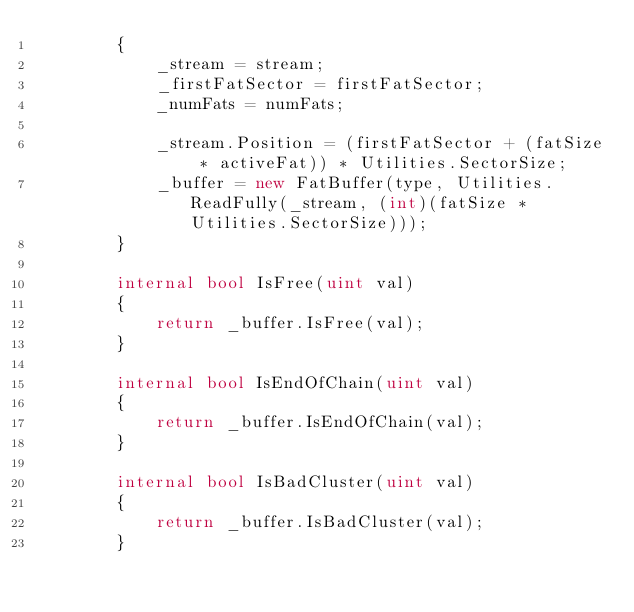Convert code to text. <code><loc_0><loc_0><loc_500><loc_500><_C#_>        {
            _stream = stream;
            _firstFatSector = firstFatSector;
            _numFats = numFats;

            _stream.Position = (firstFatSector + (fatSize * activeFat)) * Utilities.SectorSize;
            _buffer = new FatBuffer(type, Utilities.ReadFully(_stream, (int)(fatSize * Utilities.SectorSize)));
        }

        internal bool IsFree(uint val)
        {
            return _buffer.IsFree(val);
        }

        internal bool IsEndOfChain(uint val)
        {
            return _buffer.IsEndOfChain(val);
        }

        internal bool IsBadCluster(uint val)
        {
            return _buffer.IsBadCluster(val);
        }
</code> 